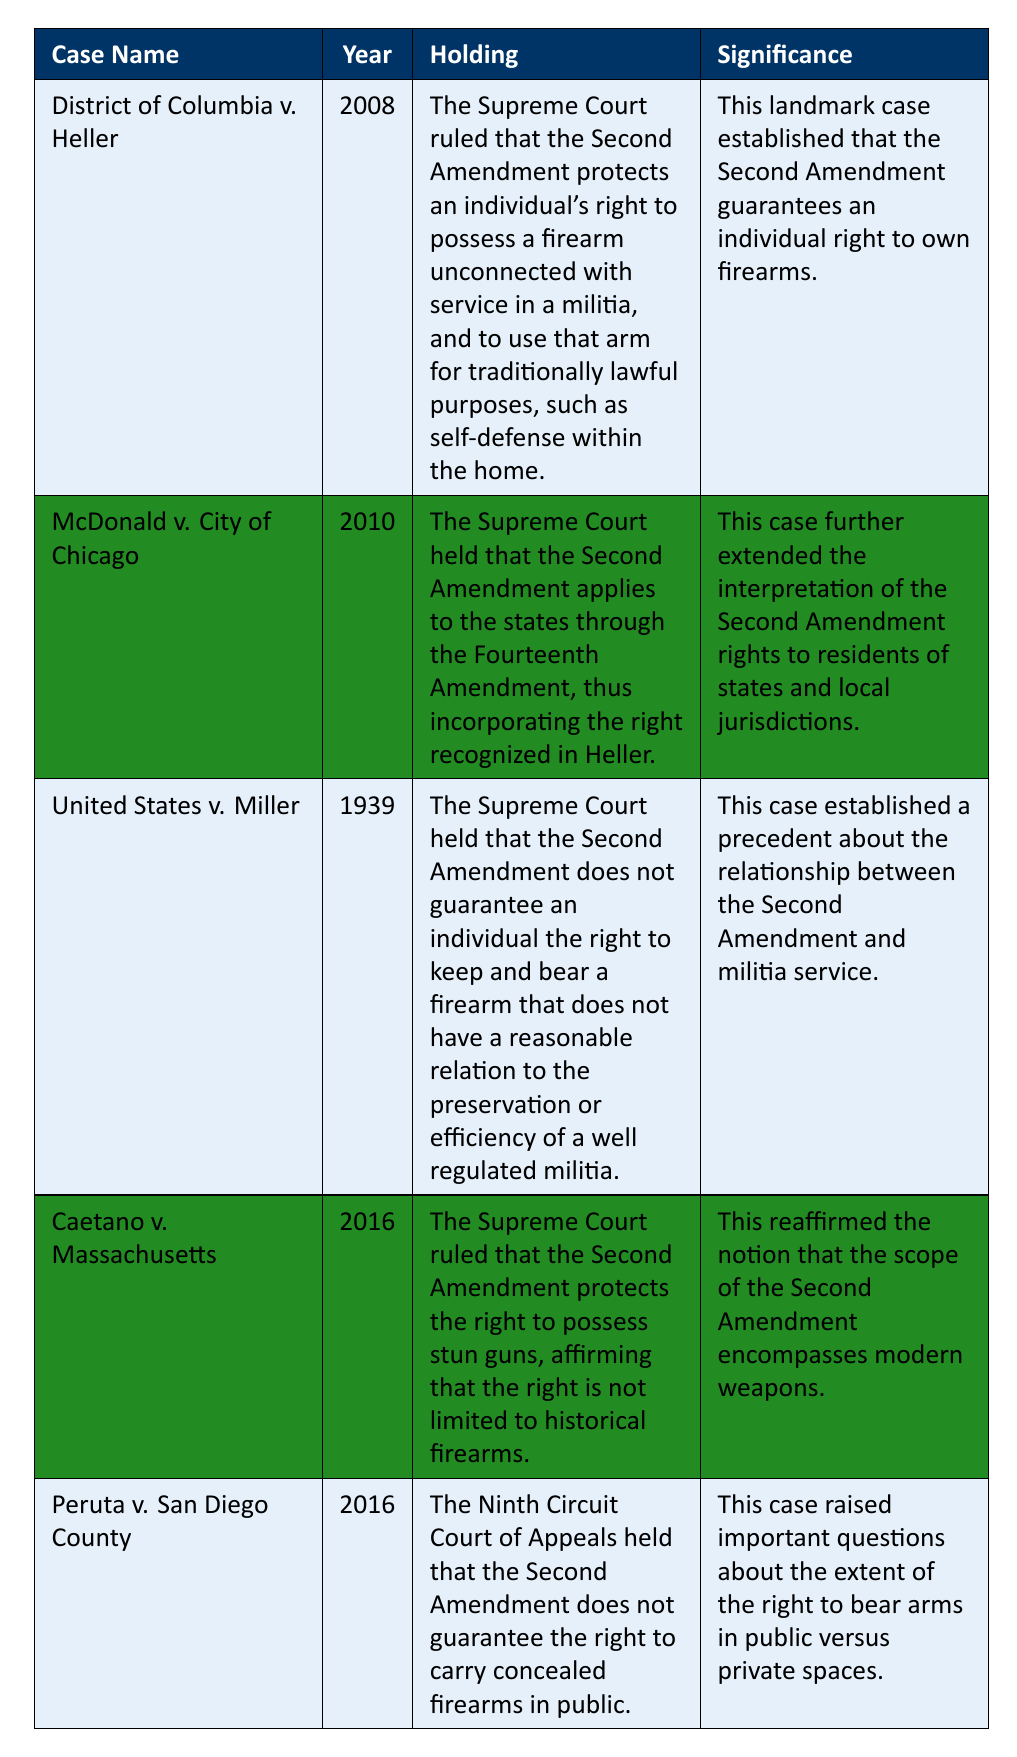What case established that the Second Amendment guarantees an individual's right to own firearms? The table indicates that "District of Columbia v. Heller" was the case that established the individual right to own firearms, as stated in its holding and significance.
Answer: District of Columbia v. Heller Which year did the Supreme Court rule that the Second Amendment applies to the states? According to the table, "McDonald v. City of Chicago" in 2010 is the case where the Supreme Court ruled the Second Amendment applies to the states, as noted in the year column.
Answer: 2010 Did the United States v. Miller case support an individual's right to keep any firearm? The table shows that the holding for "United States v. Miller" states that the Second Amendment does not guarantee the right to keep all firearms, indicating the answer is no.
Answer: No What significant legal precedent was established by United States v. Miller regarding militias? The table states that this case established a precedent about the relationship between the Second Amendment and militia service, highlighting its impact on understanding firearm rights.
Answer: Relationship between Second Amendment and militia service How many cases were decided after 2000? The table lists five cases total, with three cases ("District of Columbia v. Heller", "McDonald v. City of Chicago", and "Caetano v. Massachusetts") decided after 2000. Thus, there are three cases.
Answer: 3 In what case did the Supreme Court rule that the right to possess stun guns is protected by the Second Amendment? The holding for "Caetano v. Massachusetts" clearly states that the Supreme Court ruled on the protection of stun guns under the Second Amendment.
Answer: Caetano v. Massachusetts Which case raised questions about carrying concealed firearms in public? The ninth entry in the table identifies "Peruta v. San Diego County" as the case that raised important questions regarding concealed carry rights.
Answer: Peruta v. San Diego County What is the significance of McDonald v. City of Chicago in relation to the Second Amendment? The significance noted in the table indicates that it extended the interpretation of the Second Amendment rights to residents of states and local jurisdictions, demonstrating its importance for state-level gun rights.
Answer: Extended rights to states and local jurisdictions Which two cases were decided in the same year, 2016? The table shows that both "Caetano v. Massachusetts" and "Peruta v. San Diego County" were decided in the year 2016.
Answer: Caetano v. Massachusetts and Peruta v. San Diego County What was the holding of Caetano v. Massachusetts regarding modern weapons? The holding from "Caetano v. Massachusetts" states that the Supreme Court ruled the Second Amendment protects modern weapons like stun guns, affirming that it isn't limited to historical firearms.
Answer: Protects modern weapons like stun guns 